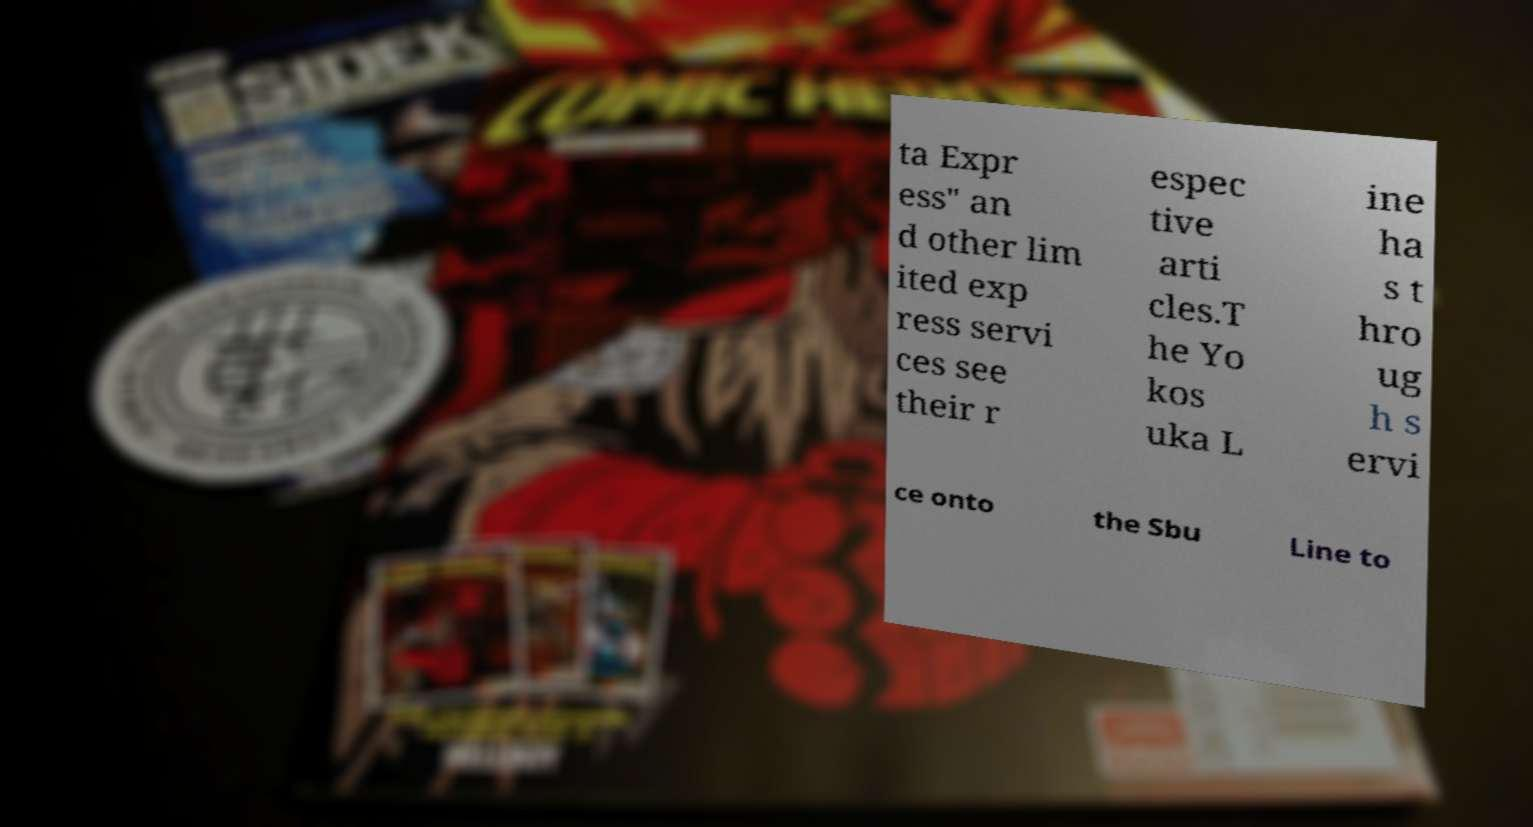There's text embedded in this image that I need extracted. Can you transcribe it verbatim? ta Expr ess" an d other lim ited exp ress servi ces see their r espec tive arti cles.T he Yo kos uka L ine ha s t hro ug h s ervi ce onto the Sbu Line to 